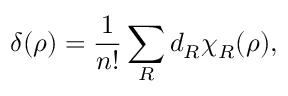Convert formula to latex. <formula><loc_0><loc_0><loc_500><loc_500>\delta ( \rho ) = \frac { 1 } { n ! } \sum _ { R } d _ { R } \chi _ { R } ( \rho ) ,</formula> 